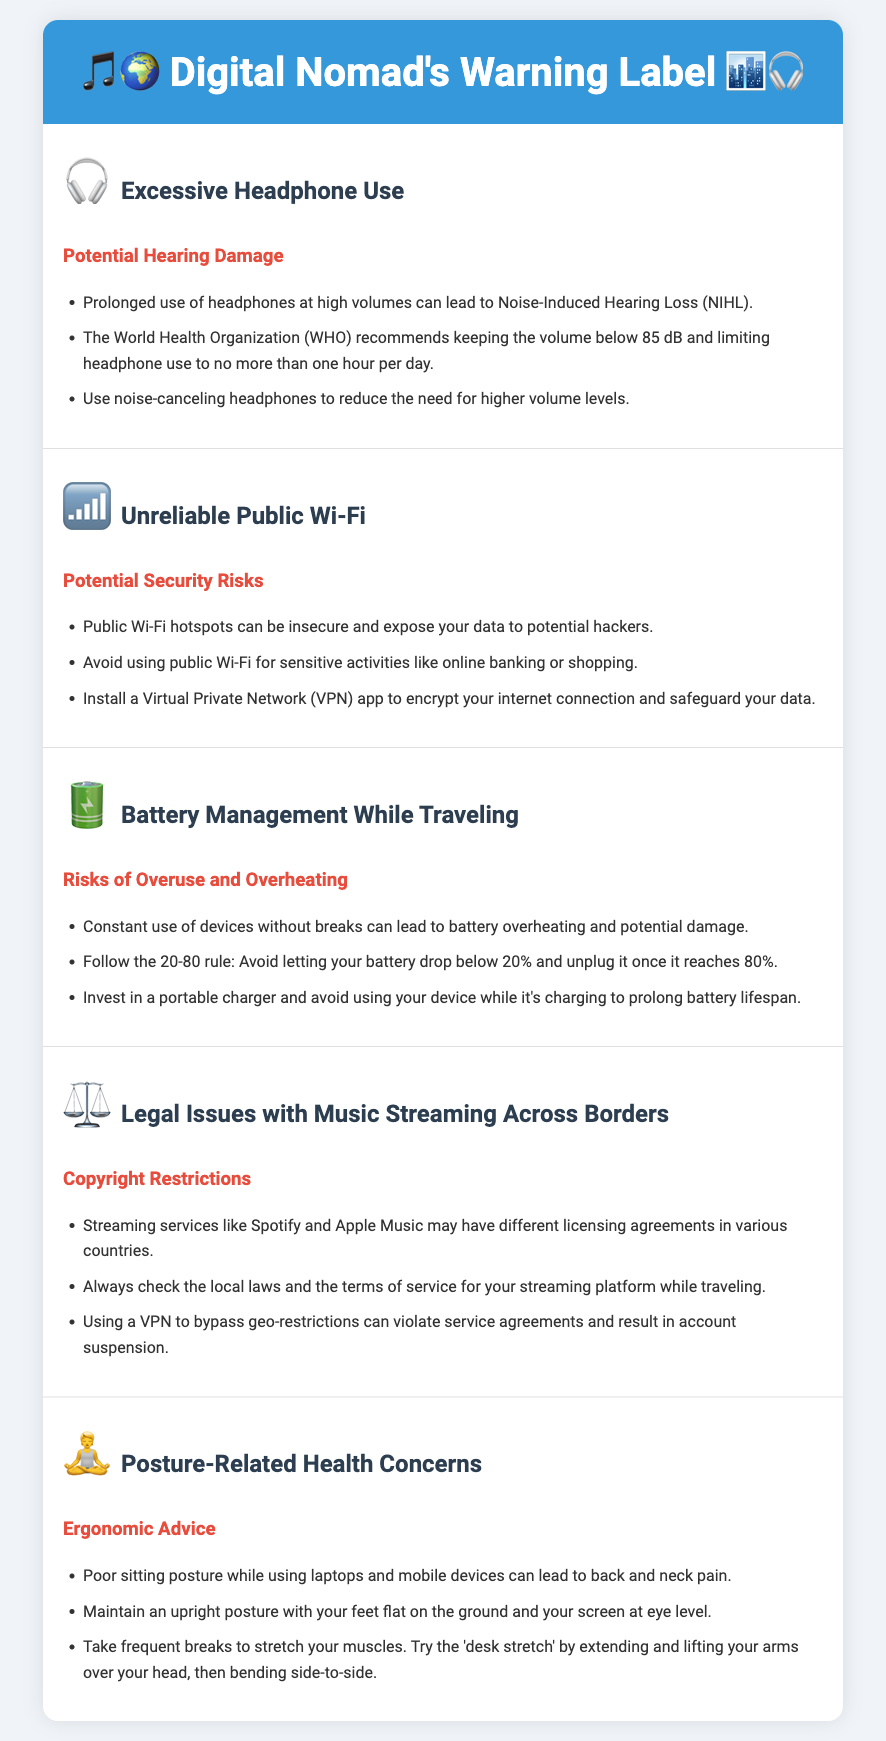What is the maximum volume recommended by WHO for headphone use? The WHO recommends keeping the volume below 85 dB to prevent hearing damage.
Answer: 85 dB What is the recommended limit for headphone use per day? It is recommended to limit headphone use to no more than one hour per day.
Answer: One hour What should you avoid using public Wi-Fi for? The warning advises avoiding public Wi-Fi for sensitive activities like online banking or shopping due to security risks.
Answer: Sensitive activities What is the 20-80 rule for battery management? The 20-80 rule advises avoiding letting your battery drop below 20% and unplugging it once it reaches 80%.
Answer: 20% and 80% What can poor sitting posture lead to? Poor sitting posture while using devices can lead to back and neck pain.
Answer: Back and neck pain What is a recommended practice to safeguard your data on public Wi-Fi? Installing a Virtual Private Network (VPN) app helps encrypt your internet connection and safeguard your data on public Wi-Fi.
Answer: Install a VPN What should you do when your battery reaches 80%? You should unplug it once it reaches 80% to prolong battery lifespan.
Answer: Unplug it What legal issue should digital nomads be aware of when streaming music? Digital nomads should be aware of different licensing agreements for streaming services in various countries.
Answer: Licensing agreements What is a suggested exercise to alleviate discomfort from poor posture? A suggested exercise is the 'desk stretch' by extending and lifting your arms over your head, then bending side-to-side.
Answer: Desk stretch 